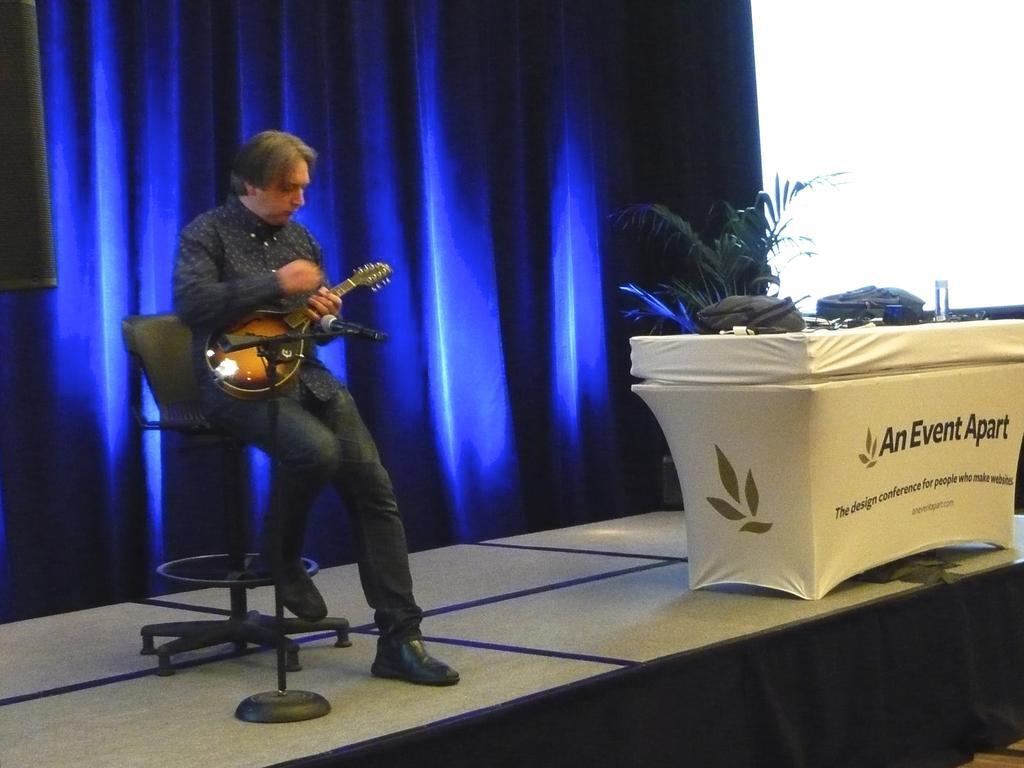Can you describe this image briefly? In this image there is a person sitting on a chair is wearing a black shirt and pant is holding a musical instrument is wearing shoes. There is a mile before him. At the background there is a curtain. At the right side there is a table having bags and glass on it, behind there is a plant. 